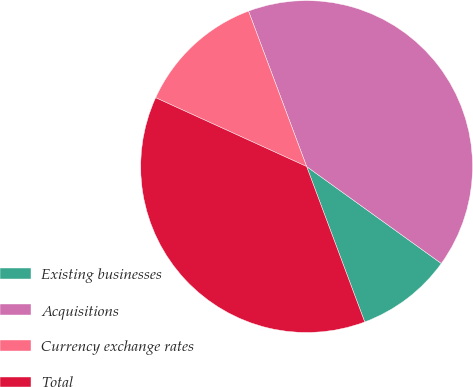<chart> <loc_0><loc_0><loc_500><loc_500><pie_chart><fcel>Existing businesses<fcel>Acquisitions<fcel>Currency exchange rates<fcel>Total<nl><fcel>9.38%<fcel>40.62%<fcel>12.5%<fcel>37.5%<nl></chart> 